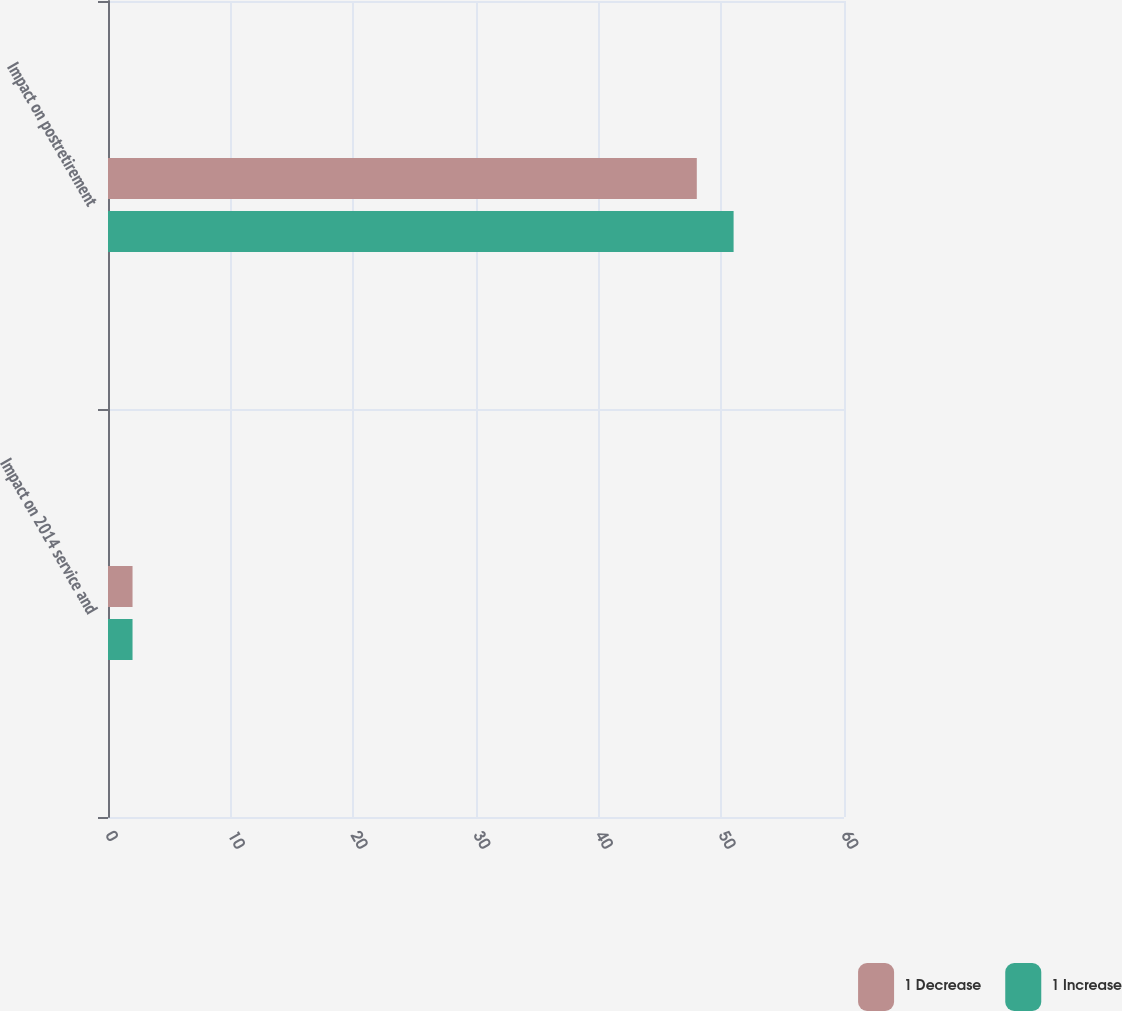<chart> <loc_0><loc_0><loc_500><loc_500><stacked_bar_chart><ecel><fcel>Impact on 2014 service and<fcel>Impact on postretirement<nl><fcel>1 Decrease<fcel>2<fcel>48<nl><fcel>1 Increase<fcel>2<fcel>51<nl></chart> 